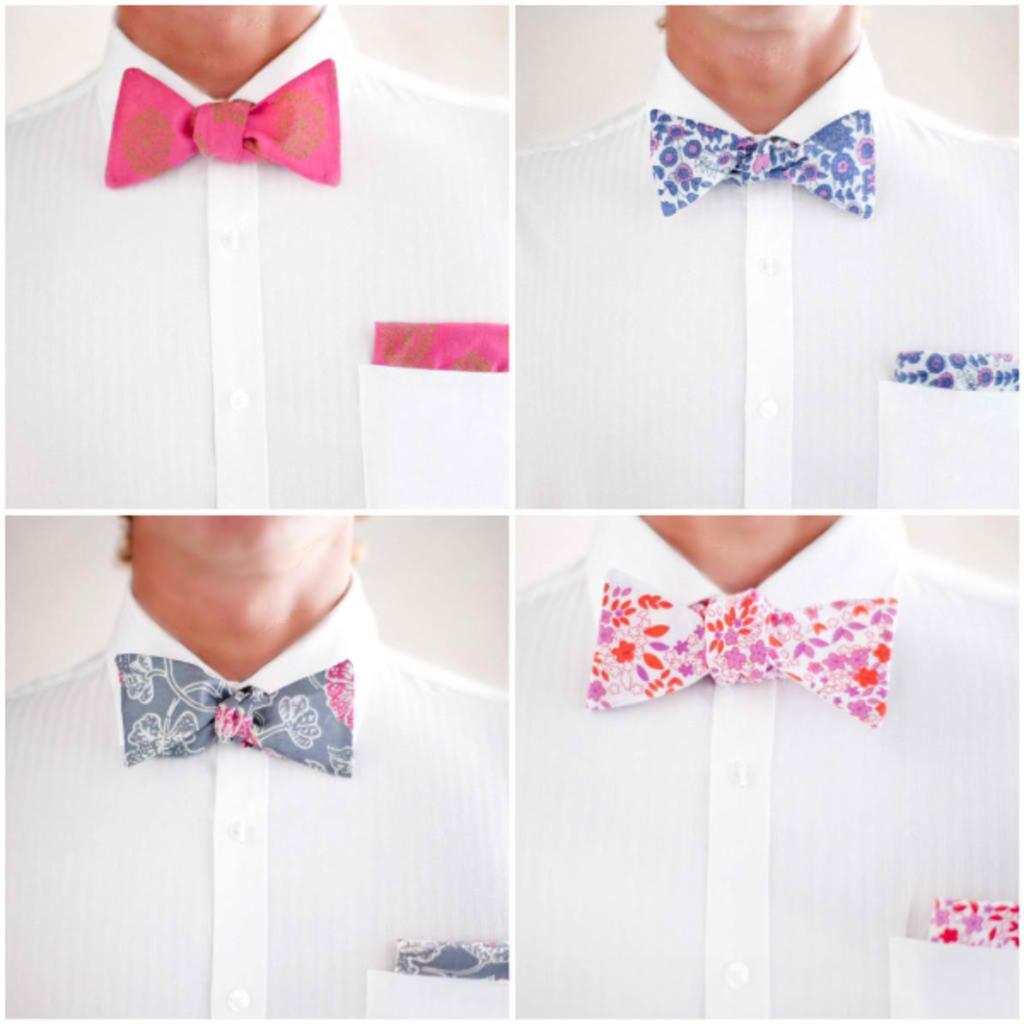How would you summarize this image in a sentence or two? Here we can see a collage of four pictures, in these four pictures we can see a person, different colors of bow ties and different colors of kerchiefs. 